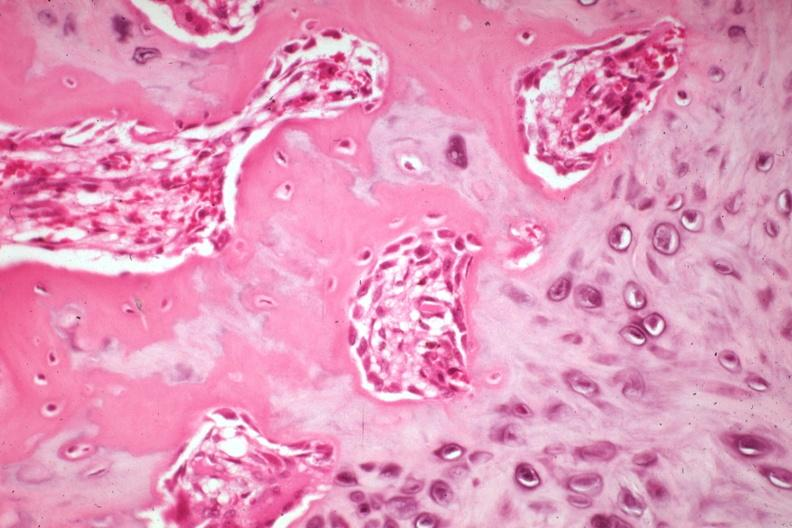what is present?
Answer the question using a single word or phrase. Joints 